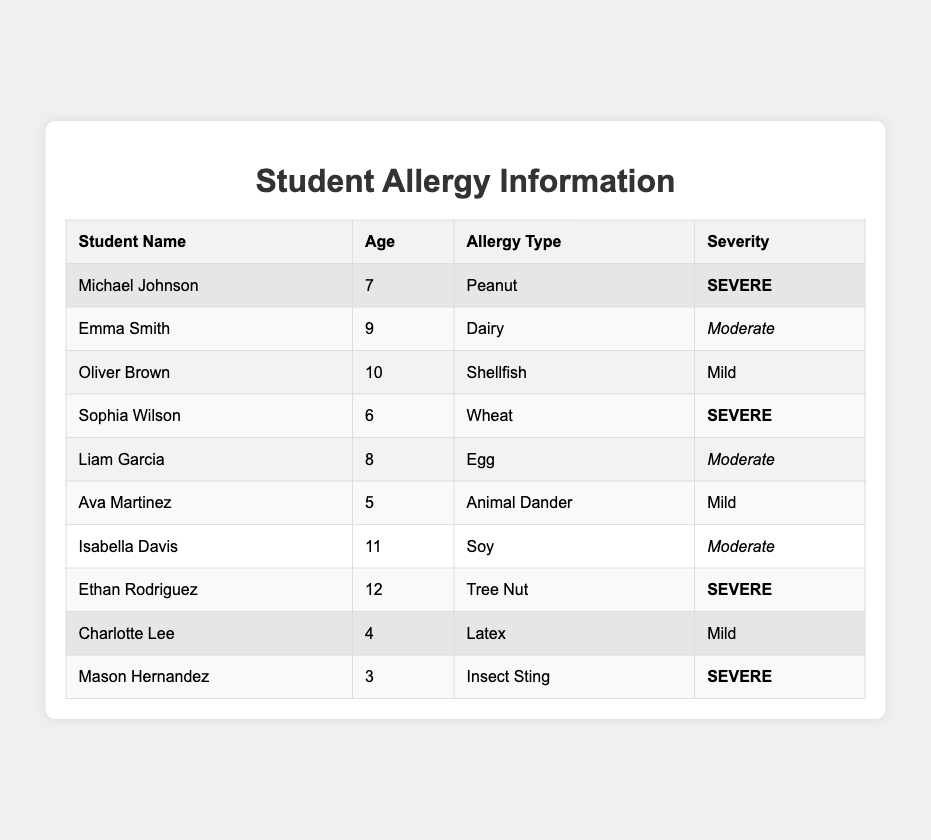What is the allergy type of Michael Johnson? According to the table, the allergy type listed for Michael Johnson is Peanut.
Answer: Peanut How many students have a severe allergy? In the table, three students (Michael Johnson, Sophia Wilson, and Mason Hernandez) have a severe allergy listed, which can be counted directly from the rows.
Answer: 3 What age is the student with a moderate dairy allergy? The table shows that Emma Smith, who has a moderate allergy to Dairy, is 9 years old.
Answer: 9 Are there any students who have a mild allergy? By examining the table, we can see that both Oliver Brown and Ava Martinez are listed with mild allergies. Therefore, the answer is yes.
Answer: Yes Which student has a severe allergy to insect sting? The table indicates that Mason Hernandez has a severe allergy to Insect Sting.
Answer: Mason Hernandez What is the total number of moderate allergies in the table? Counting from the table, there are three students with moderate allergies: Emma Smith, Liam Garcia, and Isabella Davis. Thus, the total number is 3.
Answer: 3 How many students are there in each severity category? By examining the table: 3 severe, 3 moderate, and 2 mild allergies are present. Total counts for each category: Severe (3), Moderate (3), Mild (2).
Answer: Sever: 3, Moderate: 3, Mild: 2 Who is the oldest student among those with a severe allergy? The table shows that Ethan Rodriguez is the oldest with a severe allergy (age 12), followed by Michael Johnson (age 7) and Sophia Wilson (age 6).
Answer: Ethan Rodriguez What is the average age of students with moderate allergies? The moderate allergies correspond to Emma Smith (9), Liam Garcia (8), and Isabella Davis (11). Adding those ages gives 9 + 8 + 11 = 28, and dividing by 3 results in an average of 28 / 3 = approximately 9.33.
Answer: 9.33 Is there a student with a mild latex allergy? The table shows that Charlotte Lee has a mild allergy to Latex, confirming that there is indeed a student with this allergy.
Answer: Yes 